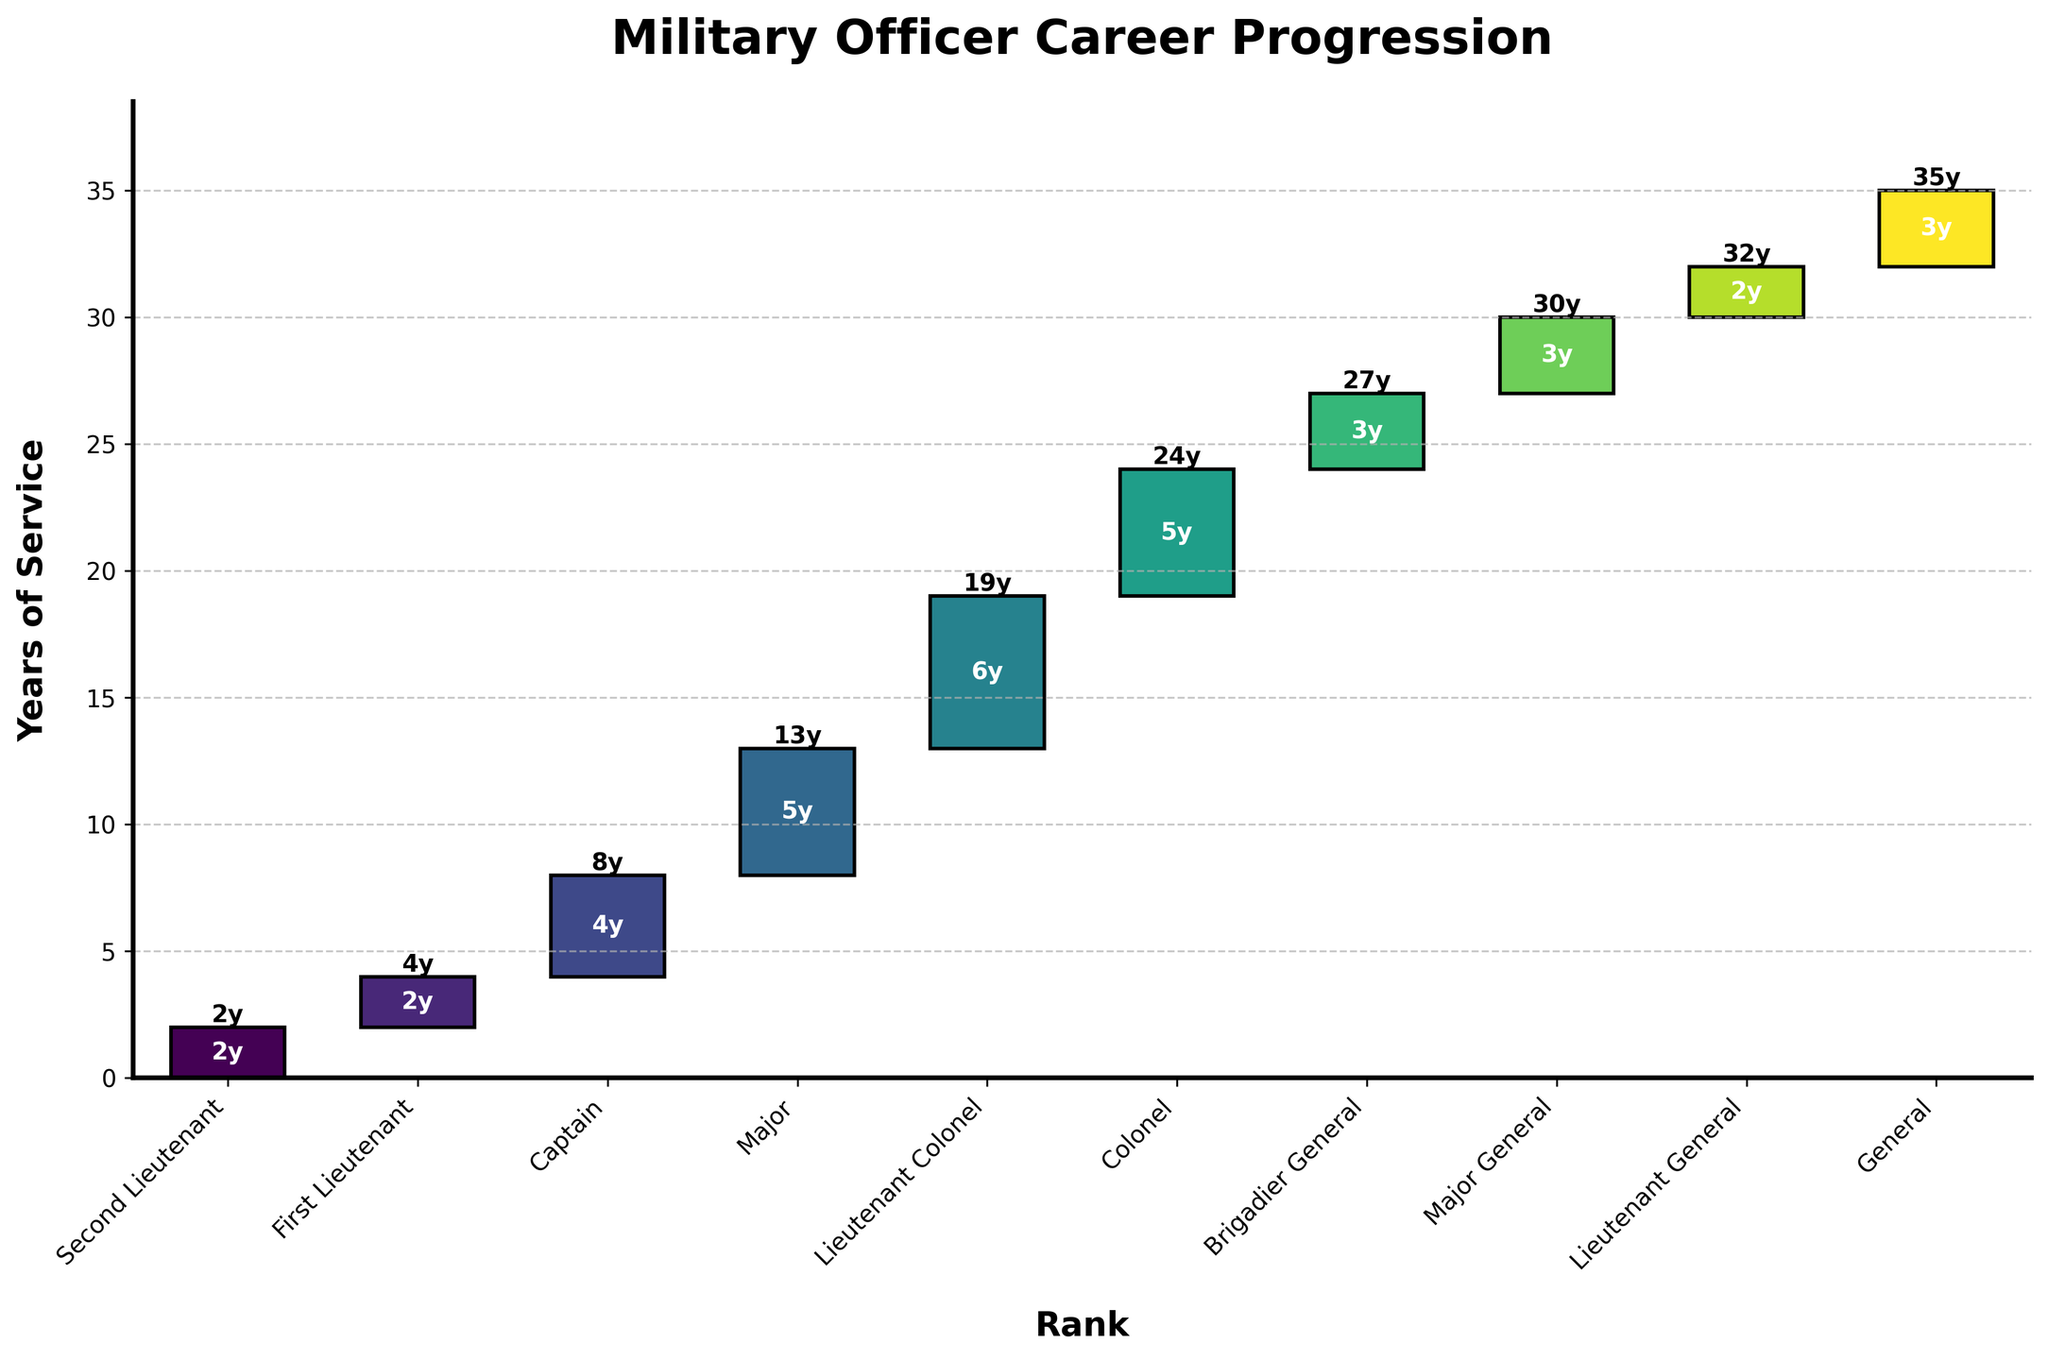What is the title of the chart? The title is located at the top of the chart and is the main heading summarizing the chart's content.
Answer: Military Officer Career Progression What is the cumulative years of service when reaching the rank of Major? Look at the top of the bar labeled 'Major' where the cumulative years are noted.
Answer: 13 Which rank requires the most years of service? Identify the rank with the tallest bar in the chart, indicating the most years required for that rank.
Answer: Lieutenant Colonel What is the total number of ranks depicted in the chart? Count the number of distinct bars representing each rank.
Answer: 10 How many years does it take to become a Brigadier General? Look at the bar representing 'Brigadier General' and read the number of years at the center of the bar.
Answer: 27 Which rank takes the least amount of years to attain? Identify the rank with the shortest bar, indicating the least number of years required.
Answer: Second Lieutenant What is the difference in cumulative years between Major and Colonel? Subtract the cumulative years for 'Major' from the cumulative years for 'Colonel'.
Answer: 24 - 13 = 11 By how many years is the service required to become a Lieutenant General shorter than that to become a General? Subtract the cumulative years for 'Lieutenant General' from the cumulative years for 'General'.
Answer: 35 - 32 = 3 In which rank is the midpoint of a military officer’s career (considering a 35-year timeline)? Find the rank where the cumulative years are closest to half of 35.
Answer: Major (13 years) What is the increase in years from First Lieutenant to Major? Subtract the cumulative years for 'First Lieutenant' from those for 'Major' to determine the increase.
Answer: 13 - 4 = 9 